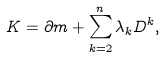Convert formula to latex. <formula><loc_0><loc_0><loc_500><loc_500>K = \partial m + \sum _ { k = 2 } ^ { n } \lambda _ { k } D ^ { k } ,</formula> 